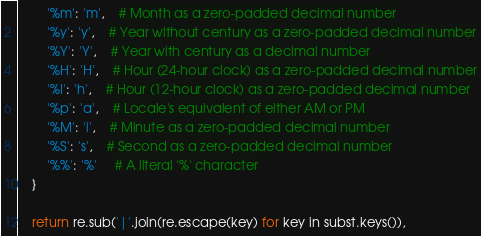Convert code to text. <code><loc_0><loc_0><loc_500><loc_500><_Python_>        '%m': 'm',    # Month as a zero-padded decimal number
        '%y': 'y',    # Year without century as a zero-padded decimal number
        '%Y': 'Y',    # Year with century as a decimal number
        '%H': 'H',    # Hour (24-hour clock) as a zero-padded decimal number
        '%I': 'h',    # Hour (12-hour clock) as a zero-padded decimal number
        '%p': 'a',    # Locale's equivalent of either AM or PM
        '%M': 'i',    # Minute as a zero-padded decimal number
        '%S': 's',    # Second as a zero-padded decimal number
        '%%': '%'     # A literal '%' character
    }

    return re.sub('|'.join(re.escape(key) for key in subst.keys()),</code> 